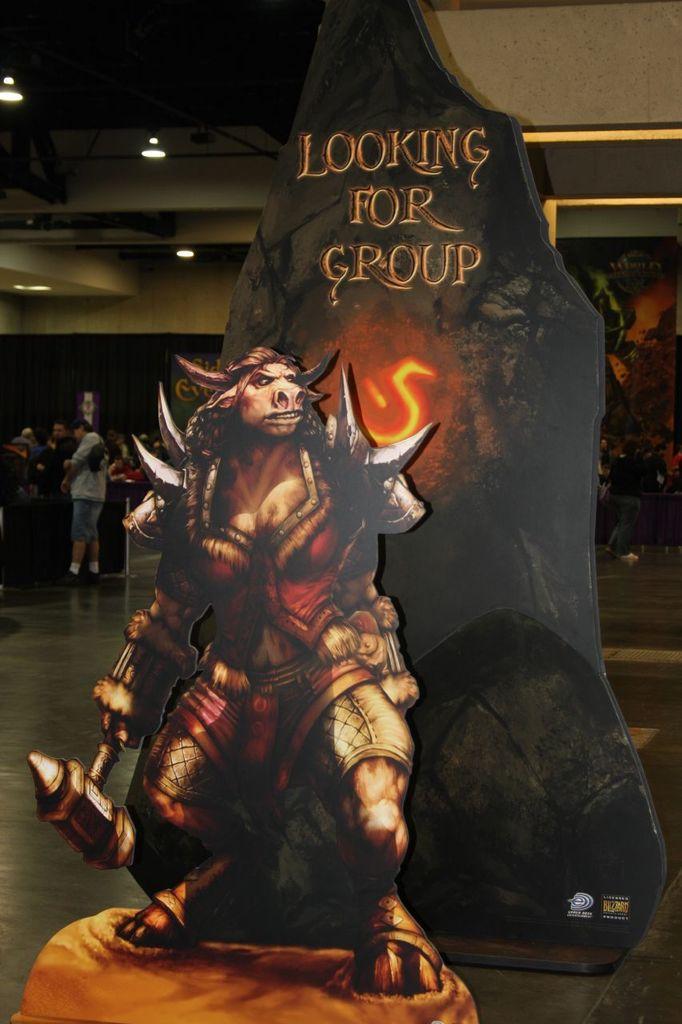Describe this image in one or two sentences. In the image there is a poster of a monster and behind the poster there is some text and in the background there are a group of people. 